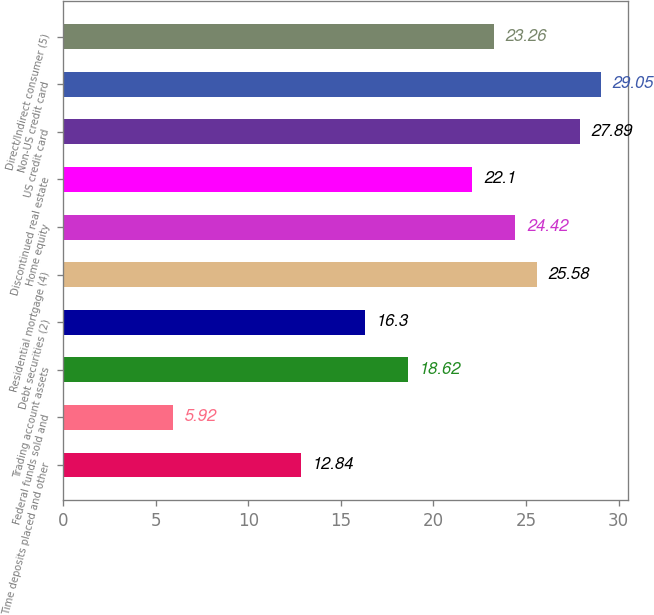Convert chart. <chart><loc_0><loc_0><loc_500><loc_500><bar_chart><fcel>Time deposits placed and other<fcel>Federal funds sold and<fcel>Trading account assets<fcel>Debt securities (2)<fcel>Residential mortgage (4)<fcel>Home equity<fcel>Discontinued real estate<fcel>US credit card<fcel>Non-US credit card<fcel>Direct/Indirect consumer (5)<nl><fcel>12.84<fcel>5.92<fcel>18.62<fcel>16.3<fcel>25.58<fcel>24.42<fcel>22.1<fcel>27.89<fcel>29.05<fcel>23.26<nl></chart> 